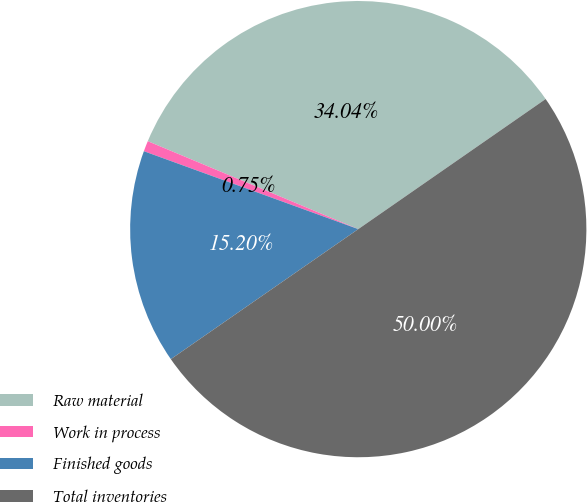Convert chart to OTSL. <chart><loc_0><loc_0><loc_500><loc_500><pie_chart><fcel>Raw material<fcel>Work in process<fcel>Finished goods<fcel>Total inventories<nl><fcel>34.04%<fcel>0.75%<fcel>15.2%<fcel>50.0%<nl></chart> 